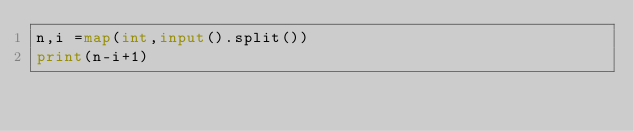Convert code to text. <code><loc_0><loc_0><loc_500><loc_500><_Python_>n,i =map(int,input().split())
print(n-i+1)</code> 